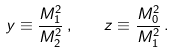Convert formula to latex. <formula><loc_0><loc_0><loc_500><loc_500>y \equiv \frac { M _ { 1 } ^ { 2 } } { M _ { 2 } ^ { 2 } } \, , \quad z \equiv \frac { M _ { 0 } ^ { 2 } } { M _ { 1 } ^ { 2 } } \, .</formula> 